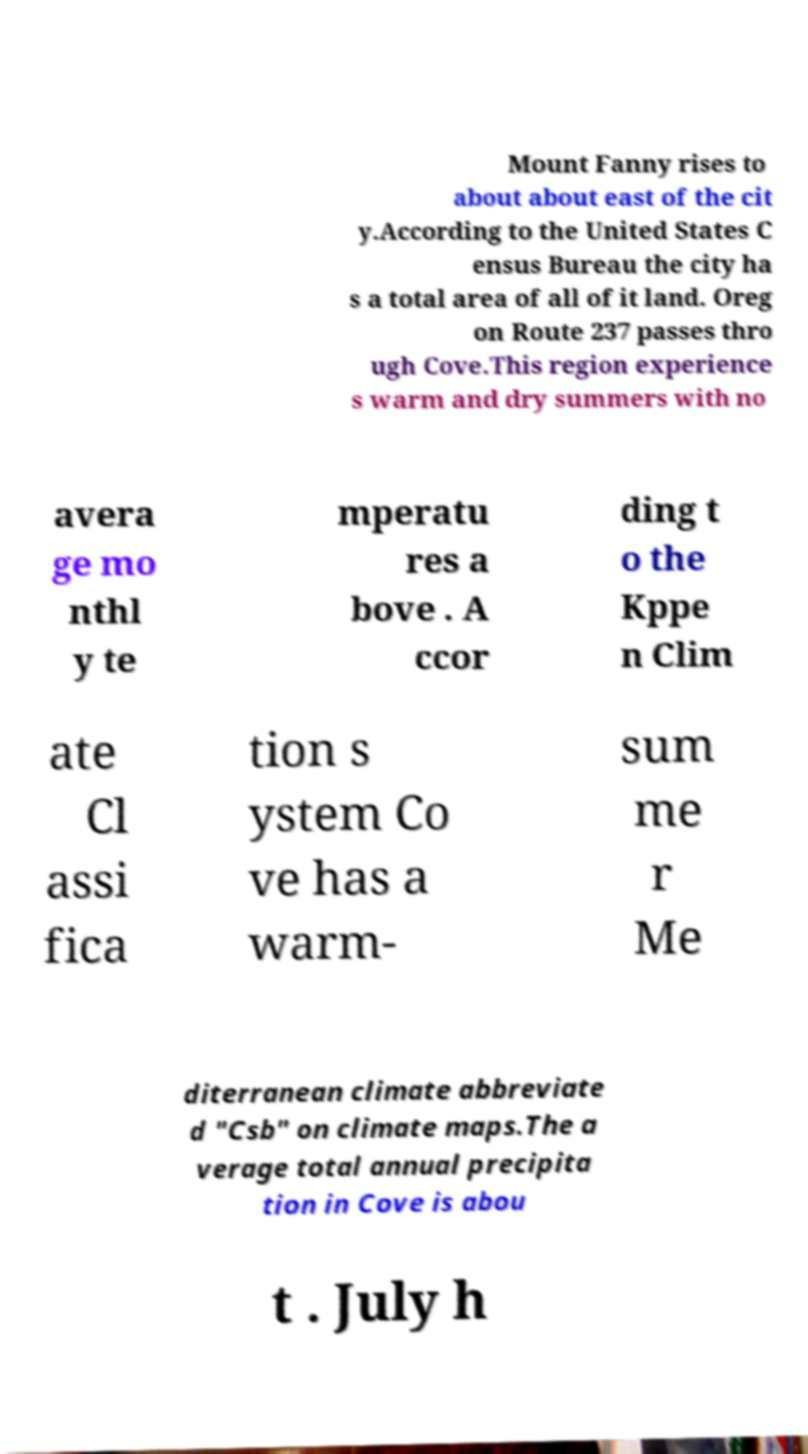There's text embedded in this image that I need extracted. Can you transcribe it verbatim? Mount Fanny rises to about about east of the cit y.According to the United States C ensus Bureau the city ha s a total area of all of it land. Oreg on Route 237 passes thro ugh Cove.This region experience s warm and dry summers with no avera ge mo nthl y te mperatu res a bove . A ccor ding t o the Kppe n Clim ate Cl assi fica tion s ystem Co ve has a warm- sum me r Me diterranean climate abbreviate d "Csb" on climate maps.The a verage total annual precipita tion in Cove is abou t . July h 